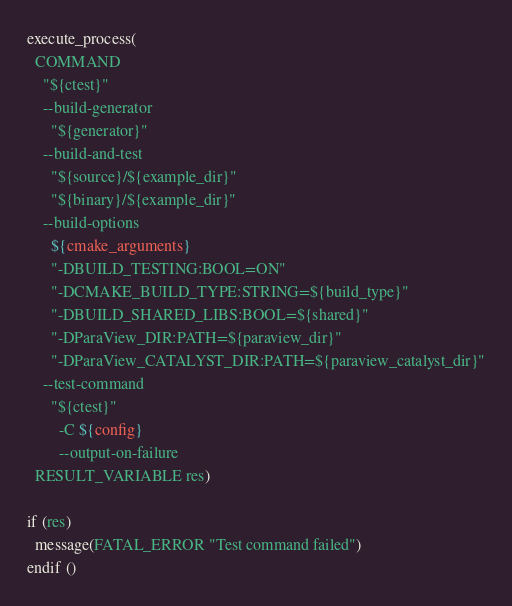<code> <loc_0><loc_0><loc_500><loc_500><_CMake_>execute_process(
  COMMAND
    "${ctest}"
    --build-generator
      "${generator}"
    --build-and-test
      "${source}/${example_dir}"
      "${binary}/${example_dir}"
    --build-options
      ${cmake_arguments}
      "-DBUILD_TESTING:BOOL=ON"
      "-DCMAKE_BUILD_TYPE:STRING=${build_type}"
      "-DBUILD_SHARED_LIBS:BOOL=${shared}"
      "-DParaView_DIR:PATH=${paraview_dir}"
      "-DParaView_CATALYST_DIR:PATH=${paraview_catalyst_dir}"
    --test-command
      "${ctest}"
        -C ${config}
        --output-on-failure
  RESULT_VARIABLE res)

if (res)
  message(FATAL_ERROR "Test command failed")
endif ()
</code> 